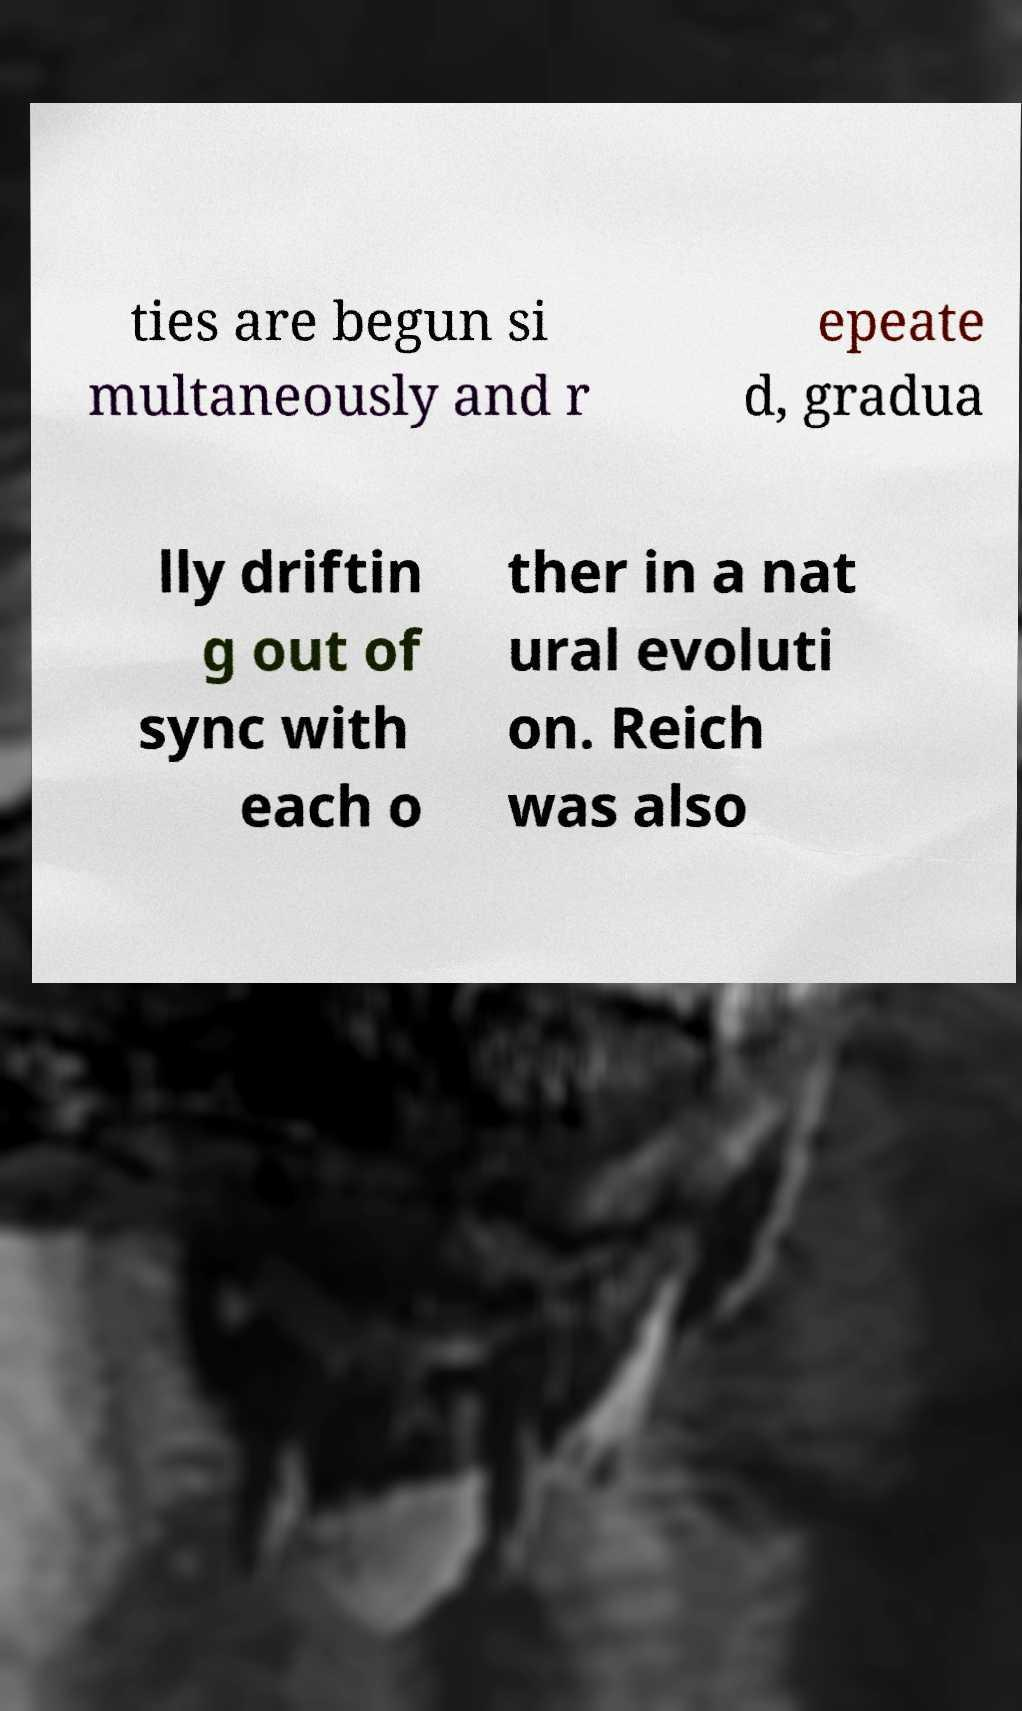Could you extract and type out the text from this image? ties are begun si multaneously and r epeate d, gradua lly driftin g out of sync with each o ther in a nat ural evoluti on. Reich was also 